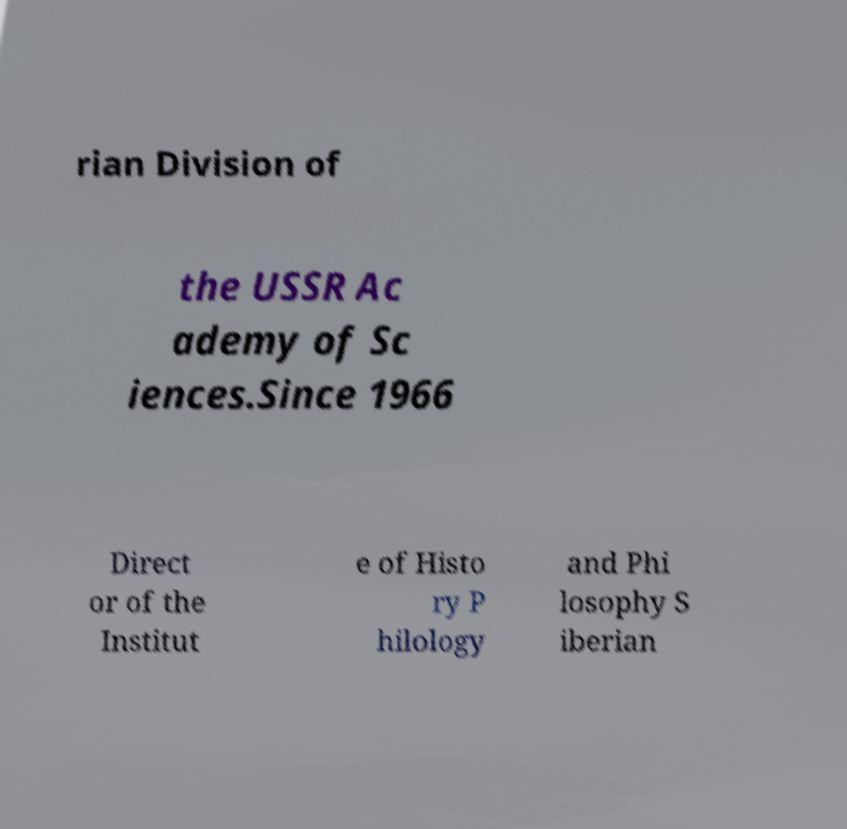Can you read and provide the text displayed in the image?This photo seems to have some interesting text. Can you extract and type it out for me? rian Division of the USSR Ac ademy of Sc iences.Since 1966 Direct or of the Institut e of Histo ry P hilology and Phi losophy S iberian 